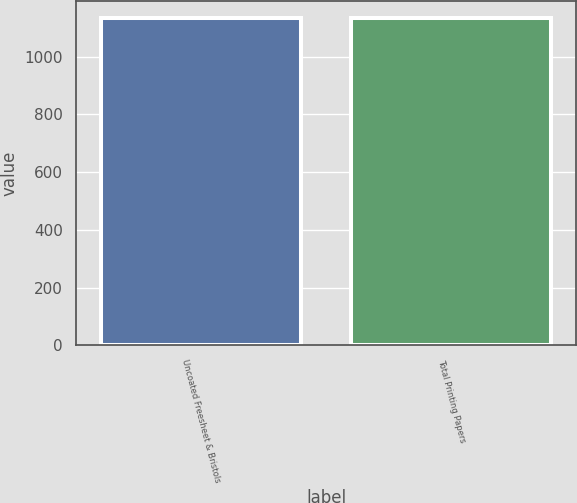<chart> <loc_0><loc_0><loc_500><loc_500><bar_chart><fcel>Uncoated Freesheet & Bristols<fcel>Total Printing Papers<nl><fcel>1135<fcel>1135.1<nl></chart> 